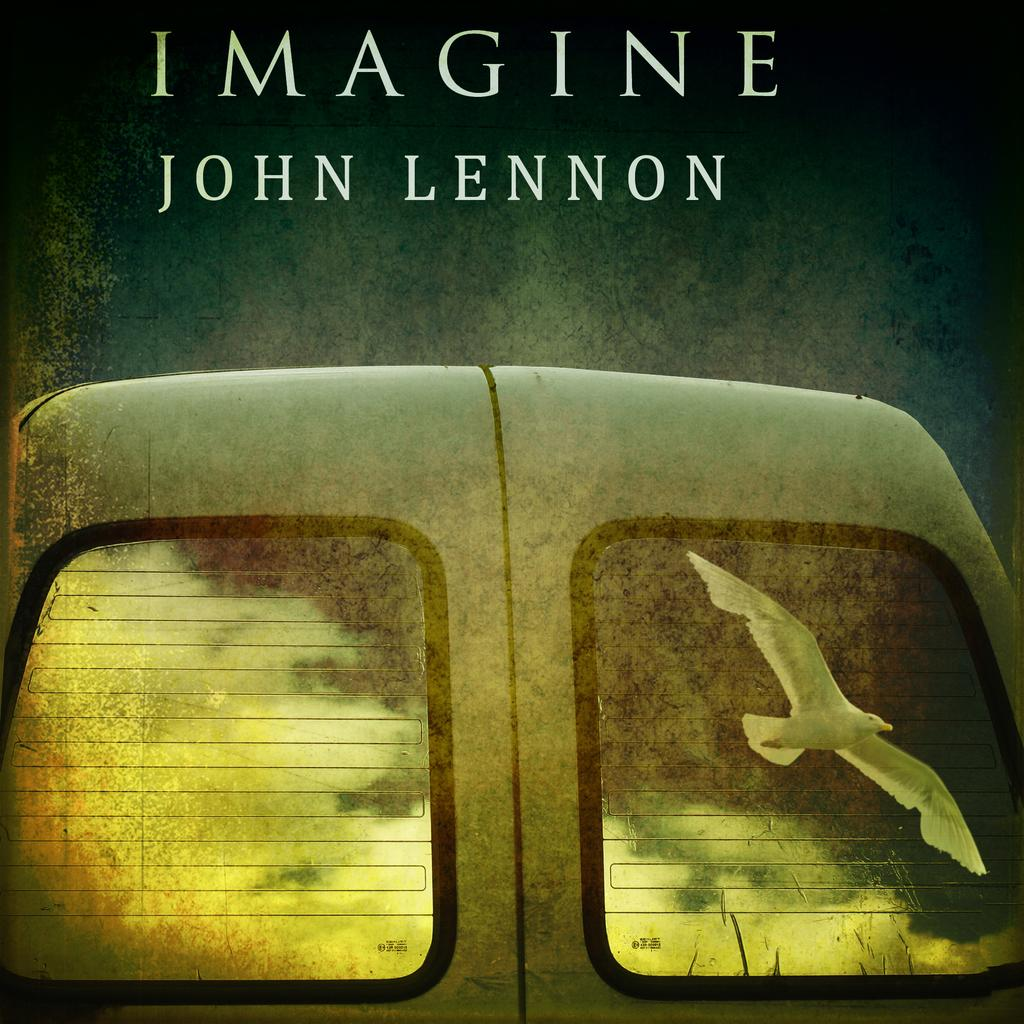What type of visual is depicted in the image? The image appears to be a poster. What can be seen inside the vehicle in the poster? There is a vehicle with glass doors in the poster. What is happening in the sky in the image? A bird is flying in the image. What else is featured on the poster besides the vehicle and bird? There are letters on the poster. Where are the scissors located in the image? There are no scissors present in the image. What type of berry is being used as a decoration on the vehicle? There is no berry present in the image, and the vehicle is not being used as a decoration. 